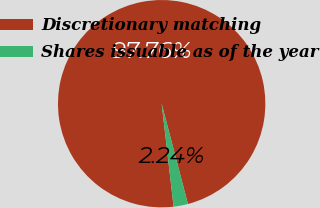Convert chart to OTSL. <chart><loc_0><loc_0><loc_500><loc_500><pie_chart><fcel>Discretionary matching<fcel>Shares issuable as of the year<nl><fcel>97.76%<fcel>2.24%<nl></chart> 